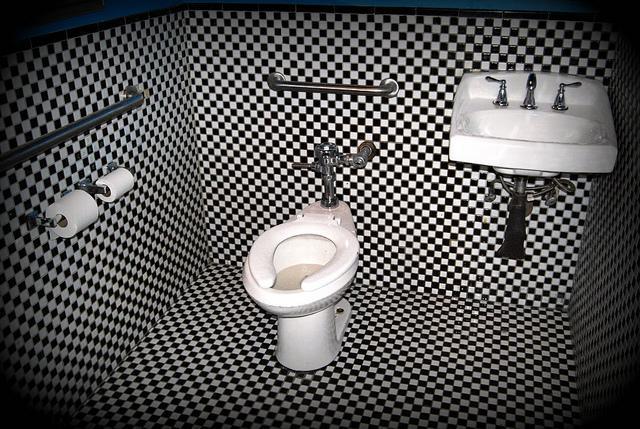How many rolls of toilet paper are there?
Give a very brief answer. 2. How many cats are on the car?
Give a very brief answer. 0. 